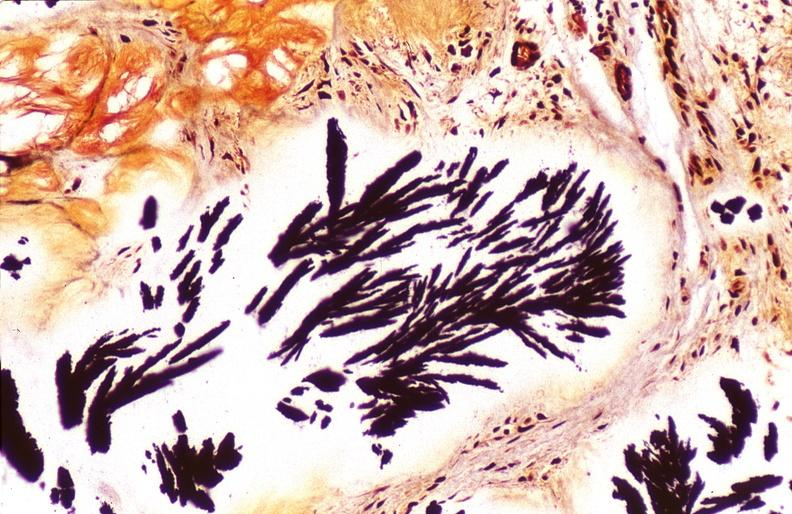does lymph node show gout, alcohol fixed tissues, monosodium urate crystals?
Answer the question using a single word or phrase. No 